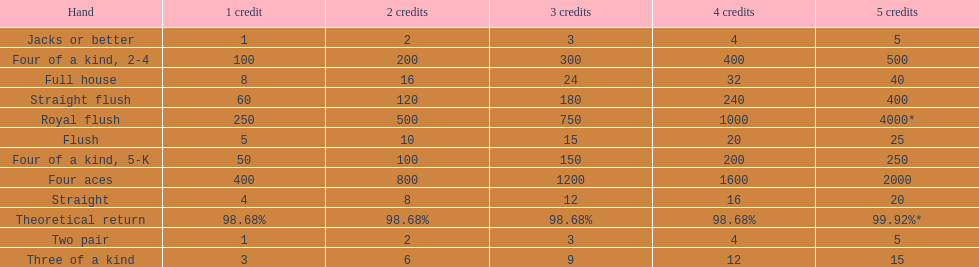How many credits do you have to spend to get at least 2000 in payout if you had four aces? 5 credits. 